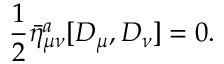<formula> <loc_0><loc_0><loc_500><loc_500>\frac { 1 } { 2 } { \bar { \eta } ^ { a } } _ { \mu \nu } [ D _ { \mu } , D _ { \nu } ] = 0 .</formula> 